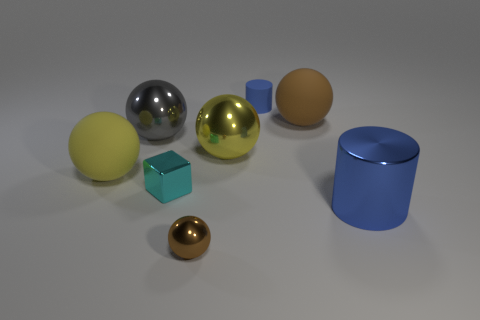Is the rubber cylinder the same color as the shiny cylinder?
Provide a succinct answer. Yes. Is the blue cylinder that is in front of the tiny cylinder made of the same material as the large thing to the left of the big gray sphere?
Keep it short and to the point. No. Are any cyan metallic objects visible?
Provide a short and direct response. Yes. There is a large thing that is to the left of the gray object; is it the same shape as the brown thing on the left side of the tiny blue rubber object?
Keep it short and to the point. Yes. Are there any large gray objects made of the same material as the large blue cylinder?
Your response must be concise. Yes. Does the brown thing that is behind the gray shiny sphere have the same material as the small cube?
Offer a terse response. No. Is the number of balls to the right of the cyan block greater than the number of yellow objects that are to the right of the yellow rubber object?
Make the answer very short. Yes. The shiny cylinder that is the same size as the gray sphere is what color?
Your answer should be very brief. Blue. Are there any small cylinders that have the same color as the big cylinder?
Your answer should be compact. Yes. Is the color of the tiny shiny object to the left of the small metallic sphere the same as the cylinder right of the large brown object?
Provide a short and direct response. No. 